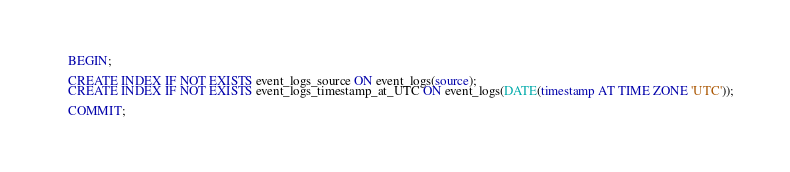<code> <loc_0><loc_0><loc_500><loc_500><_SQL_>BEGIN;

CREATE INDEX IF NOT EXISTS event_logs_source ON event_logs(source);
CREATE INDEX IF NOT EXISTS event_logs_timestamp_at_UTC ON event_logs(DATE(timestamp AT TIME ZONE 'UTC'));

COMMIT;
</code> 